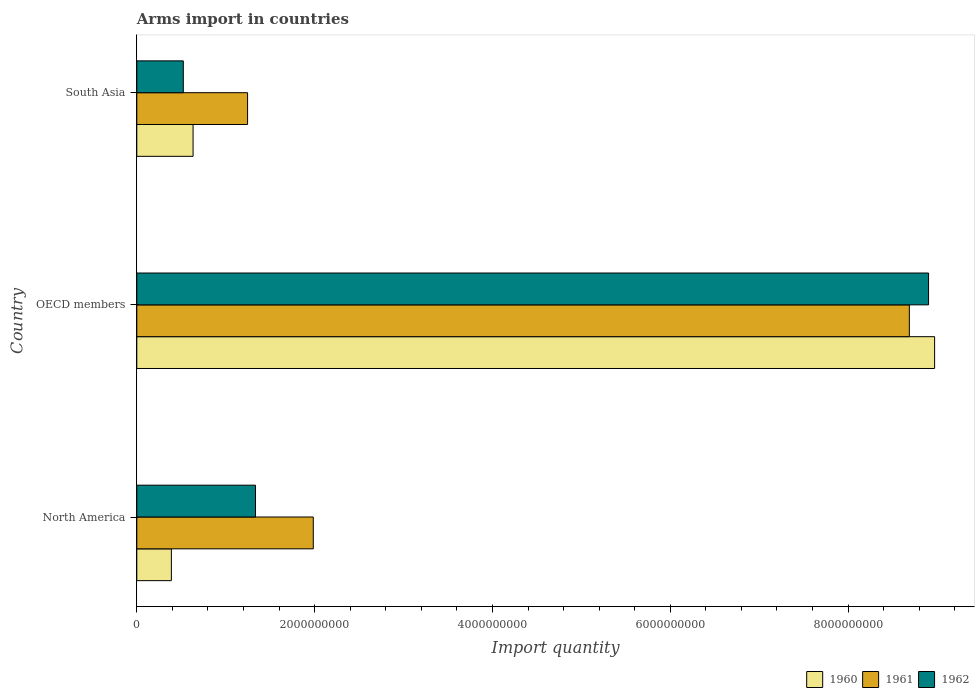How many different coloured bars are there?
Provide a short and direct response. 3. How many bars are there on the 3rd tick from the top?
Your response must be concise. 3. What is the label of the 2nd group of bars from the top?
Your answer should be very brief. OECD members. In how many cases, is the number of bars for a given country not equal to the number of legend labels?
Make the answer very short. 0. What is the total arms import in 1961 in OECD members?
Your response must be concise. 8.69e+09. Across all countries, what is the maximum total arms import in 1960?
Keep it short and to the point. 8.97e+09. Across all countries, what is the minimum total arms import in 1962?
Ensure brevity in your answer.  5.23e+08. In which country was the total arms import in 1962 maximum?
Your answer should be very brief. OECD members. In which country was the total arms import in 1961 minimum?
Give a very brief answer. South Asia. What is the total total arms import in 1960 in the graph?
Provide a short and direct response. 1.00e+1. What is the difference between the total arms import in 1962 in North America and that in OECD members?
Ensure brevity in your answer.  -7.57e+09. What is the difference between the total arms import in 1961 in North America and the total arms import in 1960 in OECD members?
Provide a short and direct response. -6.99e+09. What is the average total arms import in 1961 per country?
Provide a short and direct response. 3.97e+09. What is the difference between the total arms import in 1961 and total arms import in 1962 in OECD members?
Your response must be concise. -2.16e+08. In how many countries, is the total arms import in 1961 greater than 8800000000 ?
Ensure brevity in your answer.  0. What is the ratio of the total arms import in 1961 in North America to that in South Asia?
Ensure brevity in your answer.  1.59. What is the difference between the highest and the second highest total arms import in 1961?
Keep it short and to the point. 6.70e+09. What is the difference between the highest and the lowest total arms import in 1960?
Offer a very short reply. 8.58e+09. In how many countries, is the total arms import in 1960 greater than the average total arms import in 1960 taken over all countries?
Provide a short and direct response. 1. Is the sum of the total arms import in 1960 in North America and South Asia greater than the maximum total arms import in 1962 across all countries?
Offer a very short reply. No. What does the 1st bar from the top in South Asia represents?
Make the answer very short. 1962. What does the 3rd bar from the bottom in OECD members represents?
Give a very brief answer. 1962. Is it the case that in every country, the sum of the total arms import in 1961 and total arms import in 1960 is greater than the total arms import in 1962?
Provide a succinct answer. Yes. How many countries are there in the graph?
Provide a succinct answer. 3. Are the values on the major ticks of X-axis written in scientific E-notation?
Your answer should be very brief. No. Does the graph contain any zero values?
Ensure brevity in your answer.  No. How many legend labels are there?
Give a very brief answer. 3. What is the title of the graph?
Provide a succinct answer. Arms import in countries. What is the label or title of the X-axis?
Your answer should be compact. Import quantity. What is the Import quantity in 1960 in North America?
Offer a terse response. 3.89e+08. What is the Import quantity in 1961 in North America?
Your answer should be very brief. 1.98e+09. What is the Import quantity of 1962 in North America?
Offer a very short reply. 1.34e+09. What is the Import quantity in 1960 in OECD members?
Your response must be concise. 8.97e+09. What is the Import quantity of 1961 in OECD members?
Your answer should be very brief. 8.69e+09. What is the Import quantity of 1962 in OECD members?
Provide a succinct answer. 8.90e+09. What is the Import quantity in 1960 in South Asia?
Make the answer very short. 6.33e+08. What is the Import quantity of 1961 in South Asia?
Your answer should be compact. 1.25e+09. What is the Import quantity in 1962 in South Asia?
Your response must be concise. 5.23e+08. Across all countries, what is the maximum Import quantity in 1960?
Your response must be concise. 8.97e+09. Across all countries, what is the maximum Import quantity of 1961?
Provide a short and direct response. 8.69e+09. Across all countries, what is the maximum Import quantity of 1962?
Make the answer very short. 8.90e+09. Across all countries, what is the minimum Import quantity in 1960?
Provide a short and direct response. 3.89e+08. Across all countries, what is the minimum Import quantity of 1961?
Give a very brief answer. 1.25e+09. Across all countries, what is the minimum Import quantity in 1962?
Keep it short and to the point. 5.23e+08. What is the total Import quantity in 1960 in the graph?
Keep it short and to the point. 1.00e+1. What is the total Import quantity in 1961 in the graph?
Give a very brief answer. 1.19e+1. What is the total Import quantity of 1962 in the graph?
Provide a short and direct response. 1.08e+1. What is the difference between the Import quantity in 1960 in North America and that in OECD members?
Give a very brief answer. -8.58e+09. What is the difference between the Import quantity in 1961 in North America and that in OECD members?
Provide a succinct answer. -6.70e+09. What is the difference between the Import quantity in 1962 in North America and that in OECD members?
Your response must be concise. -7.57e+09. What is the difference between the Import quantity of 1960 in North America and that in South Asia?
Offer a very short reply. -2.44e+08. What is the difference between the Import quantity of 1961 in North America and that in South Asia?
Provide a short and direct response. 7.39e+08. What is the difference between the Import quantity in 1962 in North America and that in South Asia?
Provide a succinct answer. 8.12e+08. What is the difference between the Import quantity in 1960 in OECD members and that in South Asia?
Provide a succinct answer. 8.34e+09. What is the difference between the Import quantity of 1961 in OECD members and that in South Asia?
Your answer should be compact. 7.44e+09. What is the difference between the Import quantity in 1962 in OECD members and that in South Asia?
Give a very brief answer. 8.38e+09. What is the difference between the Import quantity of 1960 in North America and the Import quantity of 1961 in OECD members?
Offer a terse response. -8.30e+09. What is the difference between the Import quantity in 1960 in North America and the Import quantity in 1962 in OECD members?
Offer a very short reply. -8.52e+09. What is the difference between the Import quantity of 1961 in North America and the Import quantity of 1962 in OECD members?
Provide a succinct answer. -6.92e+09. What is the difference between the Import quantity of 1960 in North America and the Import quantity of 1961 in South Asia?
Provide a short and direct response. -8.57e+08. What is the difference between the Import quantity of 1960 in North America and the Import quantity of 1962 in South Asia?
Offer a very short reply. -1.34e+08. What is the difference between the Import quantity in 1961 in North America and the Import quantity in 1962 in South Asia?
Provide a succinct answer. 1.46e+09. What is the difference between the Import quantity in 1960 in OECD members and the Import quantity in 1961 in South Asia?
Provide a succinct answer. 7.73e+09. What is the difference between the Import quantity of 1960 in OECD members and the Import quantity of 1962 in South Asia?
Provide a succinct answer. 8.45e+09. What is the difference between the Import quantity in 1961 in OECD members and the Import quantity in 1962 in South Asia?
Give a very brief answer. 8.17e+09. What is the average Import quantity in 1960 per country?
Your answer should be very brief. 3.33e+09. What is the average Import quantity in 1961 per country?
Keep it short and to the point. 3.97e+09. What is the average Import quantity in 1962 per country?
Your answer should be compact. 3.59e+09. What is the difference between the Import quantity in 1960 and Import quantity in 1961 in North America?
Your answer should be compact. -1.60e+09. What is the difference between the Import quantity in 1960 and Import quantity in 1962 in North America?
Provide a succinct answer. -9.46e+08. What is the difference between the Import quantity of 1961 and Import quantity of 1962 in North America?
Provide a succinct answer. 6.50e+08. What is the difference between the Import quantity of 1960 and Import quantity of 1961 in OECD members?
Offer a very short reply. 2.84e+08. What is the difference between the Import quantity of 1960 and Import quantity of 1962 in OECD members?
Your answer should be very brief. 6.80e+07. What is the difference between the Import quantity of 1961 and Import quantity of 1962 in OECD members?
Offer a terse response. -2.16e+08. What is the difference between the Import quantity in 1960 and Import quantity in 1961 in South Asia?
Offer a terse response. -6.13e+08. What is the difference between the Import quantity in 1960 and Import quantity in 1962 in South Asia?
Offer a terse response. 1.10e+08. What is the difference between the Import quantity in 1961 and Import quantity in 1962 in South Asia?
Your answer should be very brief. 7.23e+08. What is the ratio of the Import quantity of 1960 in North America to that in OECD members?
Ensure brevity in your answer.  0.04. What is the ratio of the Import quantity in 1961 in North America to that in OECD members?
Offer a terse response. 0.23. What is the ratio of the Import quantity of 1962 in North America to that in OECD members?
Give a very brief answer. 0.15. What is the ratio of the Import quantity of 1960 in North America to that in South Asia?
Give a very brief answer. 0.61. What is the ratio of the Import quantity of 1961 in North America to that in South Asia?
Provide a short and direct response. 1.59. What is the ratio of the Import quantity in 1962 in North America to that in South Asia?
Make the answer very short. 2.55. What is the ratio of the Import quantity in 1960 in OECD members to that in South Asia?
Give a very brief answer. 14.18. What is the ratio of the Import quantity of 1961 in OECD members to that in South Asia?
Ensure brevity in your answer.  6.97. What is the ratio of the Import quantity of 1962 in OECD members to that in South Asia?
Give a very brief answer. 17.03. What is the difference between the highest and the second highest Import quantity of 1960?
Offer a very short reply. 8.34e+09. What is the difference between the highest and the second highest Import quantity in 1961?
Provide a short and direct response. 6.70e+09. What is the difference between the highest and the second highest Import quantity in 1962?
Provide a short and direct response. 7.57e+09. What is the difference between the highest and the lowest Import quantity in 1960?
Make the answer very short. 8.58e+09. What is the difference between the highest and the lowest Import quantity in 1961?
Your answer should be compact. 7.44e+09. What is the difference between the highest and the lowest Import quantity in 1962?
Give a very brief answer. 8.38e+09. 